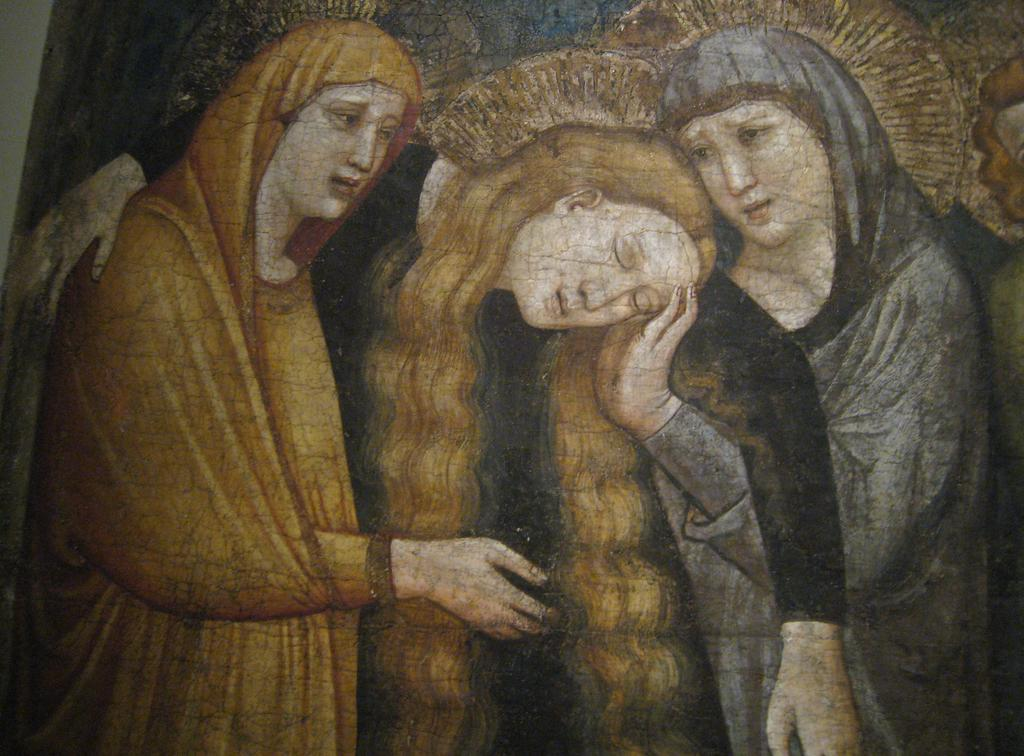What can be seen in the image? There is some art in the image. What type of representative is depicted in the art? There is no information about a representative in the image, as the fact only mentions that there is some art present. 